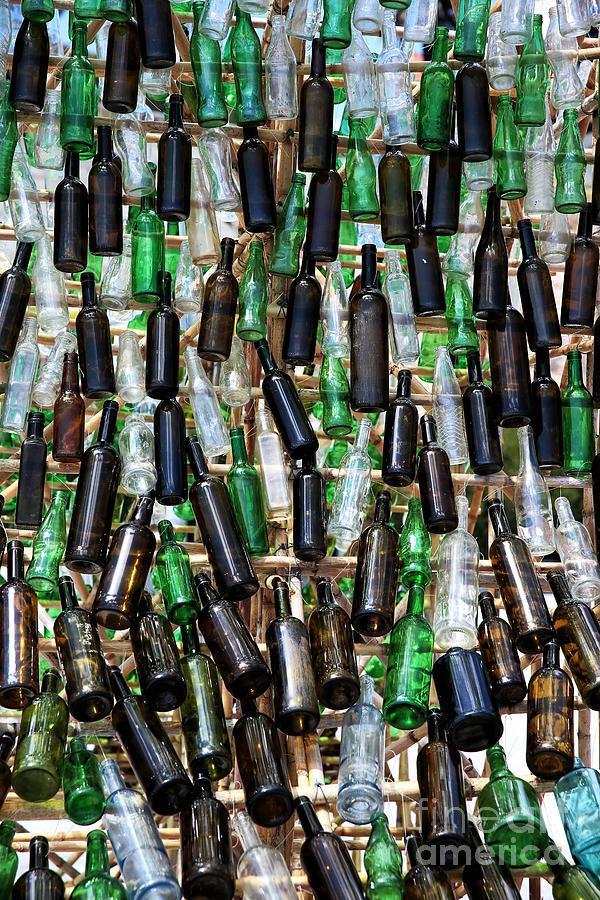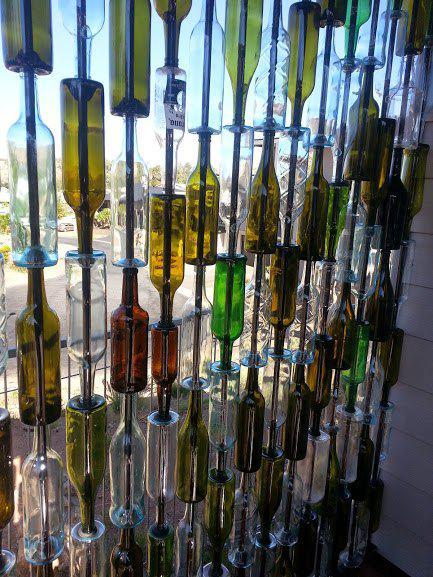The first image is the image on the left, the second image is the image on the right. Considering the images on both sides, is "Some bottles have liquor in them." valid? Answer yes or no. No. The first image is the image on the left, the second image is the image on the right. Examine the images to the left and right. Is the description "The right image shows label-less glass bottles of various colors strung on rows of vertical bars, with some rightside-up and some upside-down." accurate? Answer yes or no. Yes. 